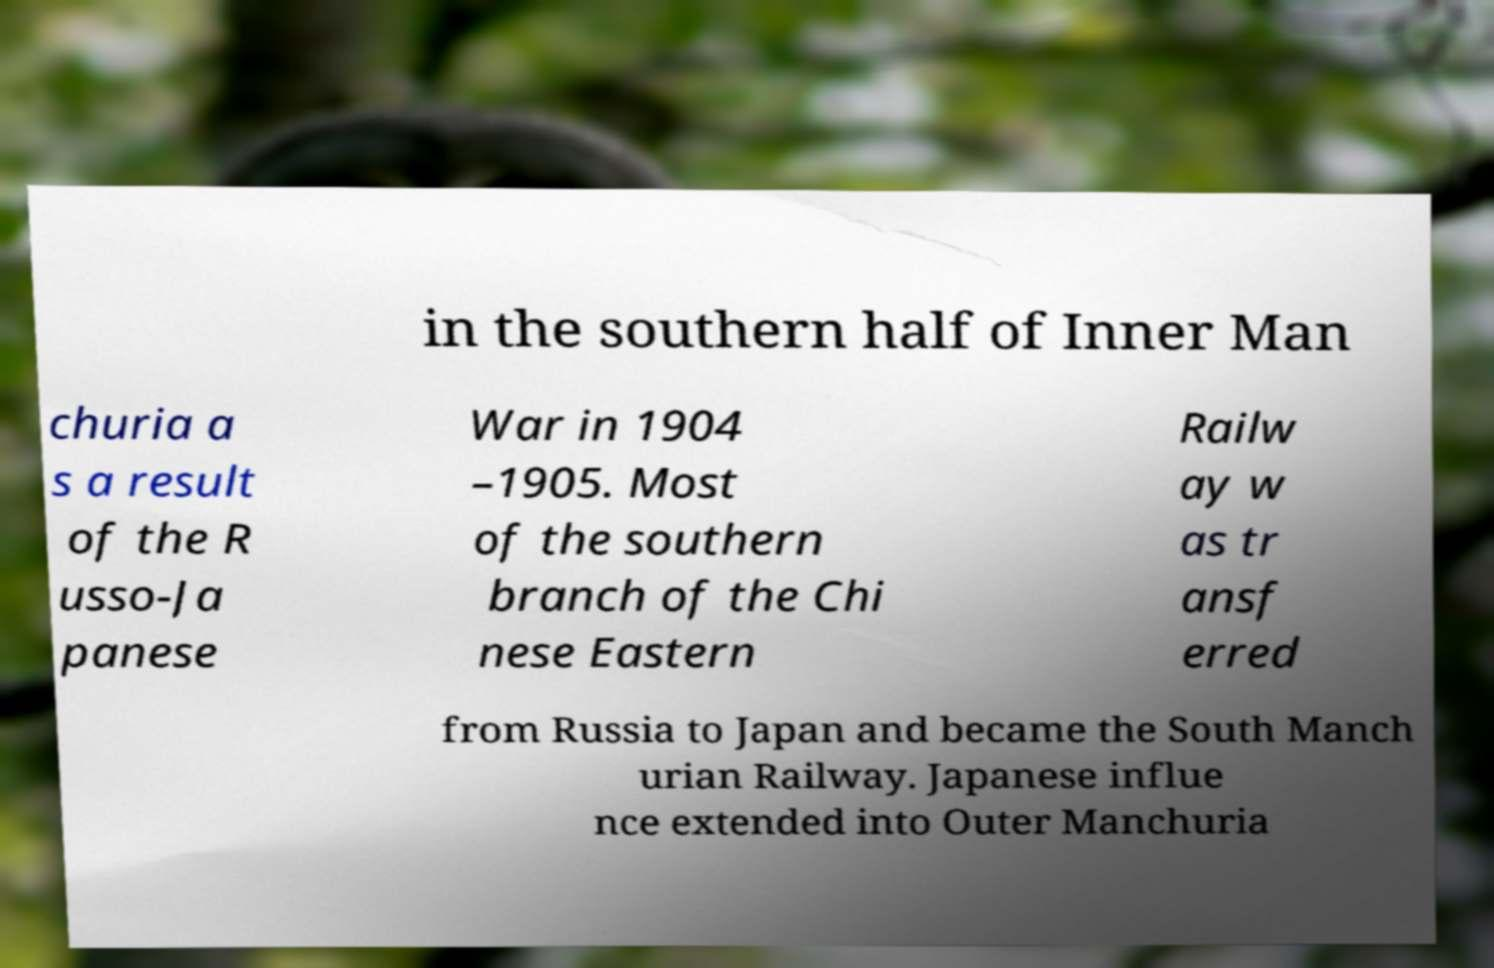Can you read and provide the text displayed in the image?This photo seems to have some interesting text. Can you extract and type it out for me? in the southern half of Inner Man churia a s a result of the R usso-Ja panese War in 1904 –1905. Most of the southern branch of the Chi nese Eastern Railw ay w as tr ansf erred from Russia to Japan and became the South Manch urian Railway. Japanese influe nce extended into Outer Manchuria 